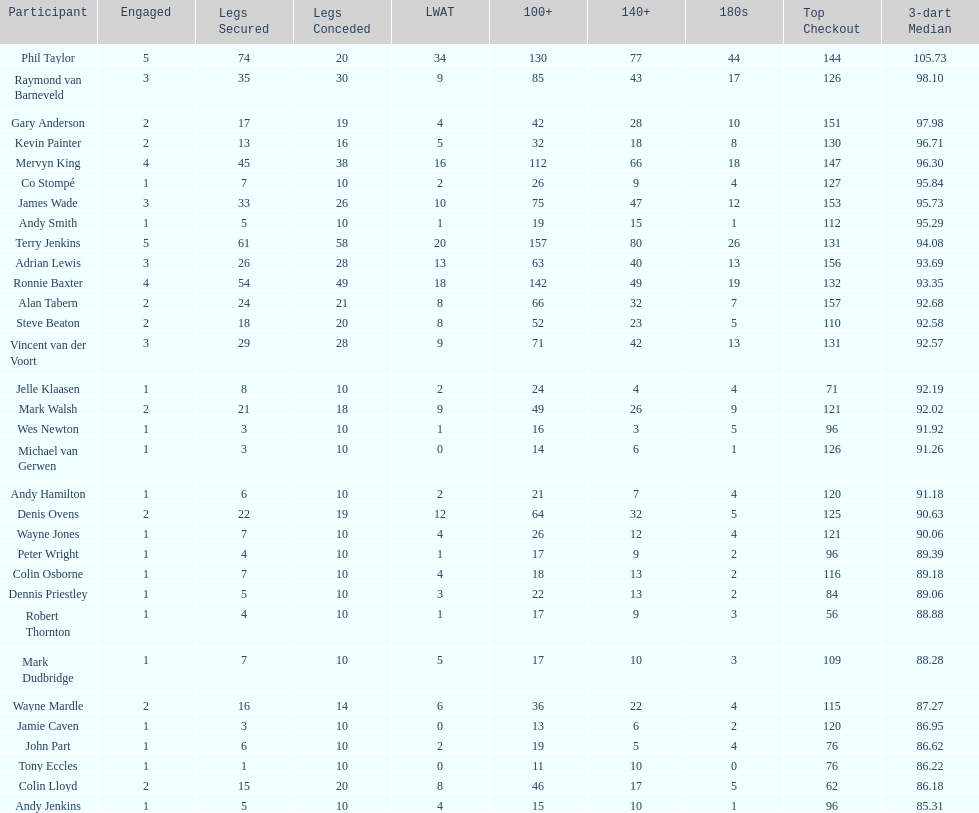What is the total amount of players who played more than 3 games? 4. 